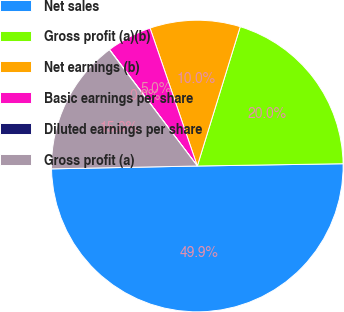Convert chart. <chart><loc_0><loc_0><loc_500><loc_500><pie_chart><fcel>Net sales<fcel>Gross profit (a)(b)<fcel>Net earnings (b)<fcel>Basic earnings per share<fcel>Diluted earnings per share<fcel>Gross profit (a)<nl><fcel>49.93%<fcel>19.99%<fcel>10.01%<fcel>5.02%<fcel>0.03%<fcel>15.0%<nl></chart> 